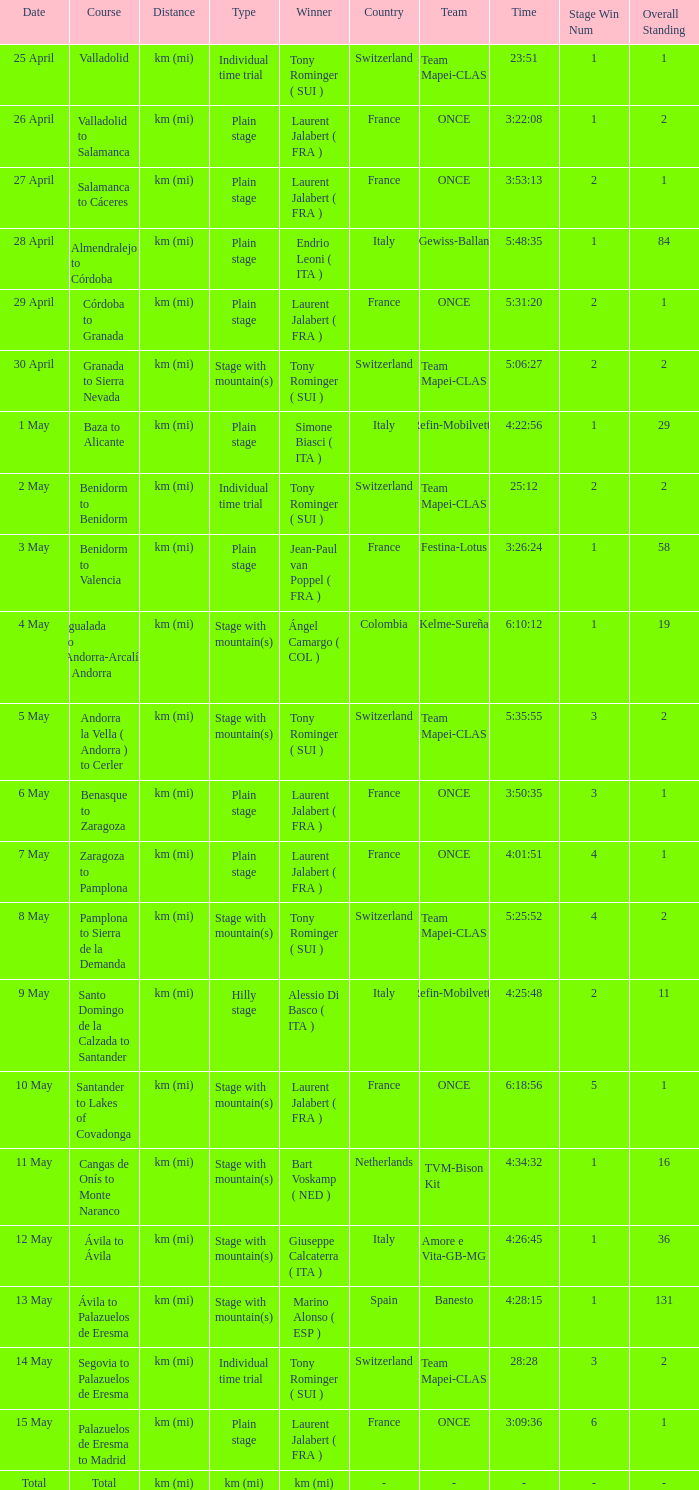What was the date with a winner of km (mi)? Total. 